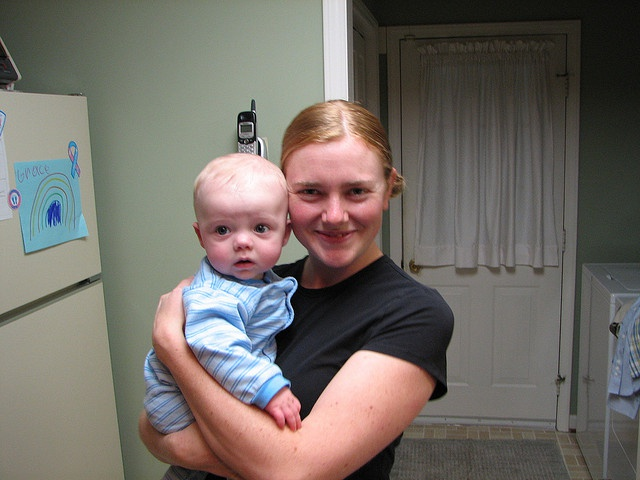Describe the objects in this image and their specific colors. I can see people in black, lightpink, brown, and lightgray tones, refrigerator in black, darkgray, gray, and lightblue tones, and cell phone in black, darkgray, gray, and lightgray tones in this image. 